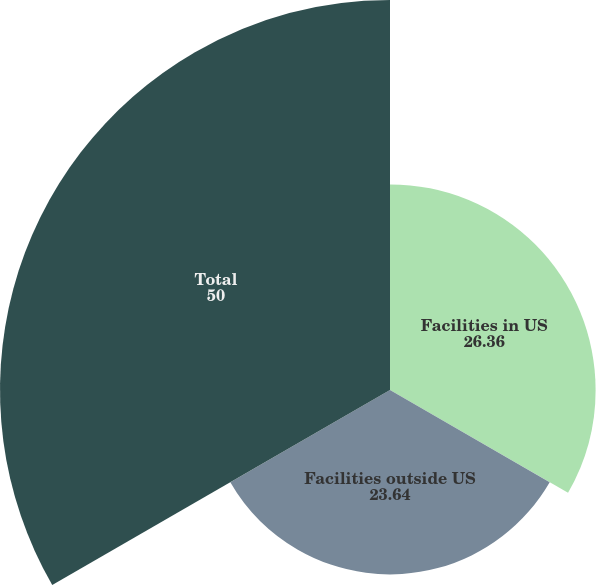<chart> <loc_0><loc_0><loc_500><loc_500><pie_chart><fcel>Facilities in US<fcel>Facilities outside US<fcel>Total<nl><fcel>26.36%<fcel>23.64%<fcel>50.0%<nl></chart> 